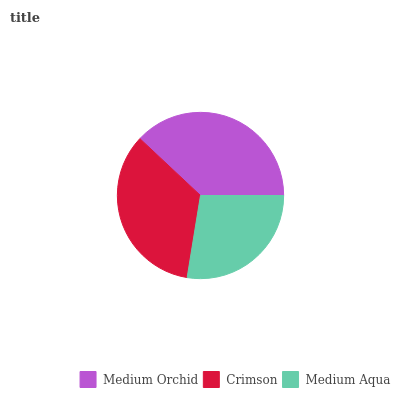Is Medium Aqua the minimum?
Answer yes or no. Yes. Is Medium Orchid the maximum?
Answer yes or no. Yes. Is Crimson the minimum?
Answer yes or no. No. Is Crimson the maximum?
Answer yes or no. No. Is Medium Orchid greater than Crimson?
Answer yes or no. Yes. Is Crimson less than Medium Orchid?
Answer yes or no. Yes. Is Crimson greater than Medium Orchid?
Answer yes or no. No. Is Medium Orchid less than Crimson?
Answer yes or no. No. Is Crimson the high median?
Answer yes or no. Yes. Is Crimson the low median?
Answer yes or no. Yes. Is Medium Orchid the high median?
Answer yes or no. No. Is Medium Orchid the low median?
Answer yes or no. No. 